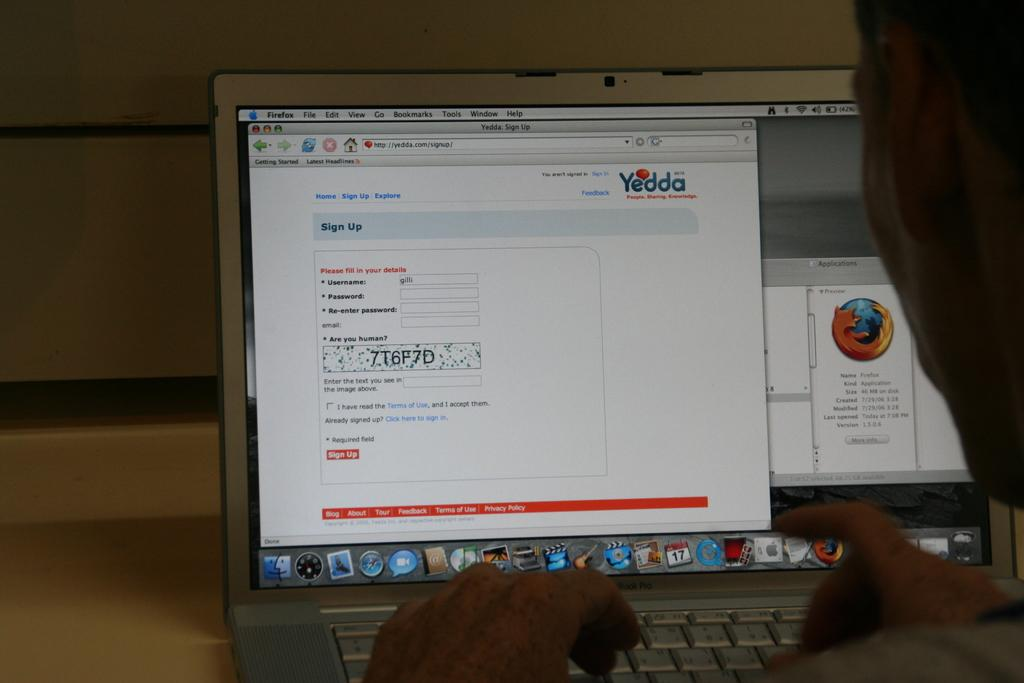<image>
Describe the image concisely. A person has just typed their username into the box. 